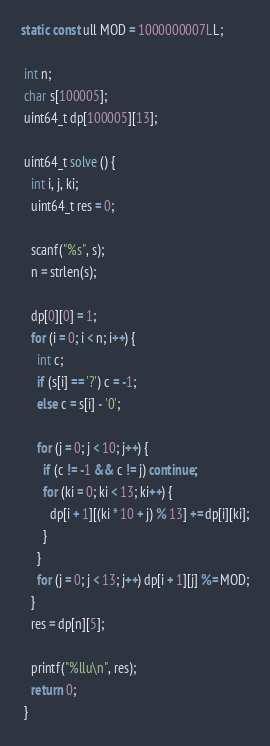Convert code to text. <code><loc_0><loc_0><loc_500><loc_500><_C#_>static const ull MOD = 1000000007LL;

 int n;
 char s[100005];
 uint64_t dp[100005][13];

 uint64_t solve () {
   int i, j, ki;
   uint64_t res = 0;

   scanf("%s", s);
   n = strlen(s);

   dp[0][0] = 1;
   for (i = 0; i < n; i++) {
     int c;
     if (s[i] == '?') c = -1;
     else c = s[i] - '0';

     for (j = 0; j < 10; j++) {
       if (c != -1 && c != j) continue;
       for (ki = 0; ki < 13; ki++) {
         dp[i + 1][(ki * 10 + j) % 13] += dp[i][ki];
       }
     }
     for (j = 0; j < 13; j++) dp[i + 1][j] %= MOD;
   }
   res = dp[n][5];

   printf("%llu\n", res);
   return 0;
 }</code> 